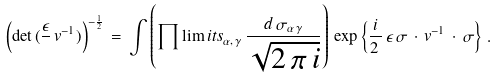<formula> <loc_0><loc_0><loc_500><loc_500>\left ( \det \, ( \frac { \epsilon } { } \, v ^ { - 1 } ) \right ) ^ { - \frac { 1 } { 2 } } \, = \, \int \left ( \prod \lim i t s _ { \alpha , \, \gamma } \, \frac { d \, \sigma _ { \alpha \, \gamma } } { \sqrt { 2 \, \pi \, i } } \right ) \, \exp \left \{ \frac { i } { 2 \, } \, \epsilon \, \sigma \, \cdot \, v ^ { - 1 } \, \cdot \, \sigma \right \} \, .</formula> 